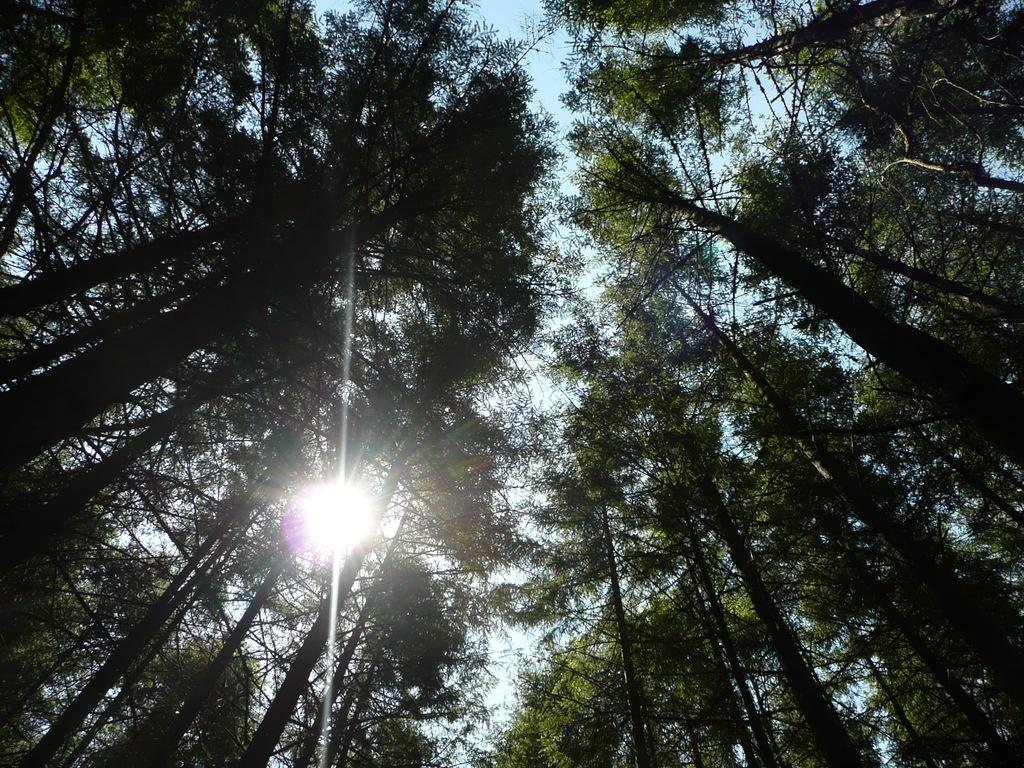What type of vegetation can be seen in the image? There is a group of trees in the image. What celestial body is visible in the image? The sun is visible in the image. What else can be seen in the sky in the image? The sky is visible in the image. What type of soap is being used to clean the trees in the image? There is no soap or cleaning activity present in the image; it features a group of trees, the sun, and the sky. Can you tell me how many people are crying in the image? There are no people or crying depicted in the image; it features a group of trees, the sun, and the sky. 